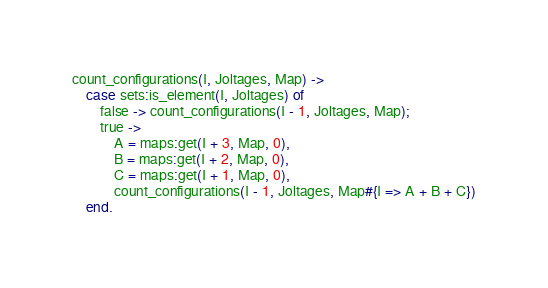Convert code to text. <code><loc_0><loc_0><loc_500><loc_500><_Erlang_>count_configurations(I, Joltages, Map) ->
    case sets:is_element(I, Joltages) of
        false -> count_configurations(I - 1, Joltages, Map);
        true ->
            A = maps:get(I + 3, Map, 0),
            B = maps:get(I + 2, Map, 0),
            C = maps:get(I + 1, Map, 0),
            count_configurations(I - 1, Joltages, Map#{I => A + B + C})
    end.
</code> 